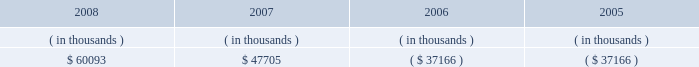Entergy new orleans , inc .
Management's financial discussion and analysis ( 1 ) includes approximately $ 30 million annually for maintenance capital , which is planned spending on routine capital projects that are necessary to support reliability of service , equipment or systems and to support normal customer growth .
( 2 ) purchase obligations represent the minimum purchase obligation or cancellation charge for contractual obligations to purchase goods or services .
For entergy new orleans , almost all of the total consists of unconditional fuel and purchased power obligations , including its obligations under the unit power sales agreement , which is discussed in note 8 to the financial statements .
In addition to the contractual obligations given above , entergy new orleans expects to make payments of approximately $ 113 million for the years 2009-2011 related to hurricane katrina and hurricane gustav restoration work and its gas rebuild project , of which $ 32 million is expected to be incurred in 2009 .
Also , entergy new orleans expects to contribute $ 1.7 million to its pension plan and $ 5.9 million to its other postretirement plans in 2009 .
Guidance pursuant to the pension protection act of 2006 rules , effective for the 2008 plan year and beyond , may affect the level of entergy new orleans' pension contributions in the future .
Also in addition to the contractual obligations , entergy new orleans has $ 26.1 million of unrecognized tax benefits and interest for which the timing of payments beyond 12 months cannot be reasonably estimated due to uncertainties in the timing of effective settlement of tax positions .
See note 3 to the financial statements for additional information regarding unrecognized tax benefits .
The planned capital investment estimate for entergy new orleans reflects capital required to support existing business .
The estimated capital expenditures are subject to periodic review and modification and may vary based on the ongoing effects of regulatory constraints , environmental compliance , market volatility , economic trends , and the ability to access capital .
Management provides more information on long-term debt and preferred stock maturities in notes 5 and 6 and to the financial statements .
Sources of capital entergy new orleans' sources to meet its capital requirements include : internally generated funds ; cash on hand ; and debt and preferred stock issuances .
Entergy new orleans' receivables from or ( payables to ) the money pool were as follows as of december 31 for each of the following years: .
See note 4 to the financial statements for a description of the money pool .
As discussed above in "bankruptcy proceedings" , entergy new orleans issued notes due in three years in satisfaction of its affiliate prepetition accounts payable , including its indebtedness to the entergy system money pool of $ 37.2 million .
Entergy new orleans has obtained short-term borrowing authorization from the ferc under which it may borrow through march 2010 , up to the aggregate amount , at any one time outstanding , of $ 100 million .
See note 4 to the financial statements for further discussion of entergy new orleans' short-term borrowing limits .
The long- term securities issuances of entergy new orleans are limited to amounts authorized by the city council , and the current authorization extends through august 2010. .
How is cash flow of entergy new orleans affected by the change in balance of money pool from 2007 to 2008 , in thousands? 
Computations: (47705 - 60093)
Answer: -12388.0. Entergy new orleans , inc .
Management's financial discussion and analysis ( 1 ) includes approximately $ 30 million annually for maintenance capital , which is planned spending on routine capital projects that are necessary to support reliability of service , equipment or systems and to support normal customer growth .
( 2 ) purchase obligations represent the minimum purchase obligation or cancellation charge for contractual obligations to purchase goods or services .
For entergy new orleans , almost all of the total consists of unconditional fuel and purchased power obligations , including its obligations under the unit power sales agreement , which is discussed in note 8 to the financial statements .
In addition to the contractual obligations given above , entergy new orleans expects to make payments of approximately $ 113 million for the years 2009-2011 related to hurricane katrina and hurricane gustav restoration work and its gas rebuild project , of which $ 32 million is expected to be incurred in 2009 .
Also , entergy new orleans expects to contribute $ 1.7 million to its pension plan and $ 5.9 million to its other postretirement plans in 2009 .
Guidance pursuant to the pension protection act of 2006 rules , effective for the 2008 plan year and beyond , may affect the level of entergy new orleans' pension contributions in the future .
Also in addition to the contractual obligations , entergy new orleans has $ 26.1 million of unrecognized tax benefits and interest for which the timing of payments beyond 12 months cannot be reasonably estimated due to uncertainties in the timing of effective settlement of tax positions .
See note 3 to the financial statements for additional information regarding unrecognized tax benefits .
The planned capital investment estimate for entergy new orleans reflects capital required to support existing business .
The estimated capital expenditures are subject to periodic review and modification and may vary based on the ongoing effects of regulatory constraints , environmental compliance , market volatility , economic trends , and the ability to access capital .
Management provides more information on long-term debt and preferred stock maturities in notes 5 and 6 and to the financial statements .
Sources of capital entergy new orleans' sources to meet its capital requirements include : internally generated funds ; cash on hand ; and debt and preferred stock issuances .
Entergy new orleans' receivables from or ( payables to ) the money pool were as follows as of december 31 for each of the following years: .
See note 4 to the financial statements for a description of the money pool .
As discussed above in "bankruptcy proceedings" , entergy new orleans issued notes due in three years in satisfaction of its affiliate prepetition accounts payable , including its indebtedness to the entergy system money pool of $ 37.2 million .
Entergy new orleans has obtained short-term borrowing authorization from the ferc under which it may borrow through march 2010 , up to the aggregate amount , at any one time outstanding , of $ 100 million .
See note 4 to the financial statements for further discussion of entergy new orleans' short-term borrowing limits .
The long- term securities issuances of entergy new orleans are limited to amounts authorized by the city council , and the current authorization extends through august 2010. .
What potion of the expected payments related to hurricane katrina and hurricane gustav restoration work and its gas rebuild project will be incurred during 2009? 
Computations: (32 / 113)
Answer: 0.28319. 